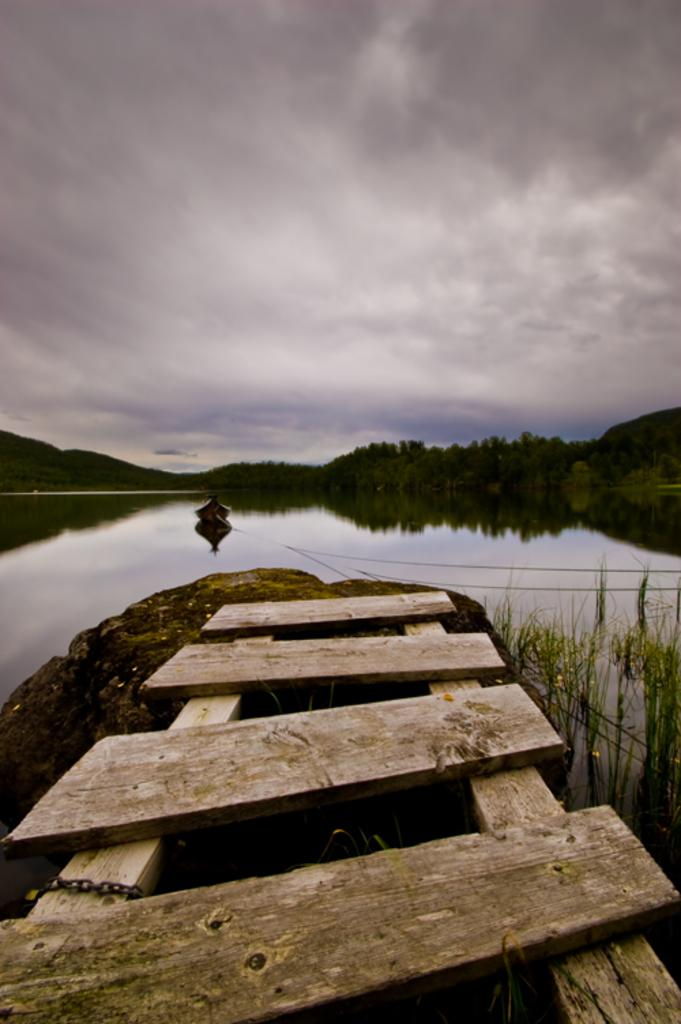What type of wooden object is in the image? There is a wooden object in the image, but the specific type is not mentioned. What is attached to the wooden object? There is a chain in the image, and it is attached to the wooden object. What is the main subject of the image? The main subject of the image is a boat. What is the condition of the water in the image? Grass is visible in the water, which suggests it might be a marsh or a shallow body of water. What can be seen in the background of the image? Trees are visible in the background of the image. What is the weather like in the image? The sky is cloudy in the image. Where is the sister standing in the image? There is no mention of a sister or anyone standing in the image. What type of mailbox is present in the image? There is no mailbox present in the image. 